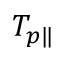Convert formula to latex. <formula><loc_0><loc_0><loc_500><loc_500>T _ { p \| }</formula> 